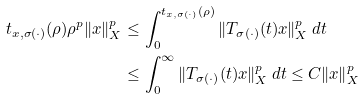Convert formula to latex. <formula><loc_0><loc_0><loc_500><loc_500>t _ { x , \sigma ( \cdot ) } ( \rho ) \rho ^ { p } \| x \| _ { X } ^ { p } & \leq \int _ { 0 } ^ { t _ { x , \sigma ( \cdot ) } ( \rho ) } \| T _ { \sigma ( \cdot ) } ( t ) x \| _ { X } ^ { p } \, d t \\ & \leq \int _ { 0 } ^ { \infty } \| T _ { \sigma ( \cdot ) } ( t ) x \| _ { X } ^ { p } \, d t \leq C \| x \| _ { X } ^ { p }</formula> 